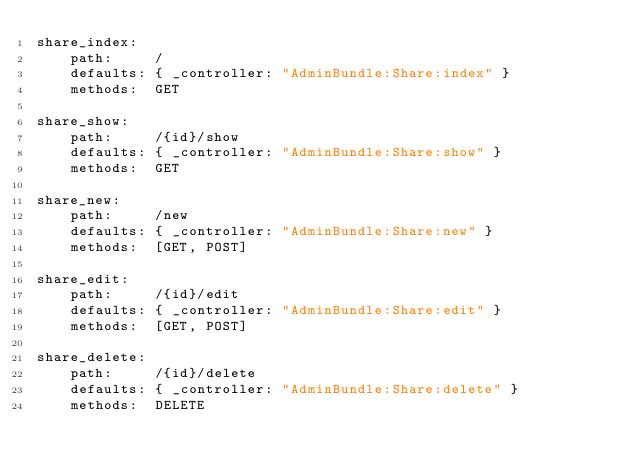Convert code to text. <code><loc_0><loc_0><loc_500><loc_500><_YAML_>share_index:
    path:     /
    defaults: { _controller: "AdminBundle:Share:index" }
    methods:  GET

share_show:
    path:     /{id}/show
    defaults: { _controller: "AdminBundle:Share:show" }
    methods:  GET

share_new:
    path:     /new
    defaults: { _controller: "AdminBundle:Share:new" }
    methods:  [GET, POST]

share_edit:
    path:     /{id}/edit
    defaults: { _controller: "AdminBundle:Share:edit" }
    methods:  [GET, POST]

share_delete:
    path:     /{id}/delete
    defaults: { _controller: "AdminBundle:Share:delete" }
    methods:  DELETE
</code> 